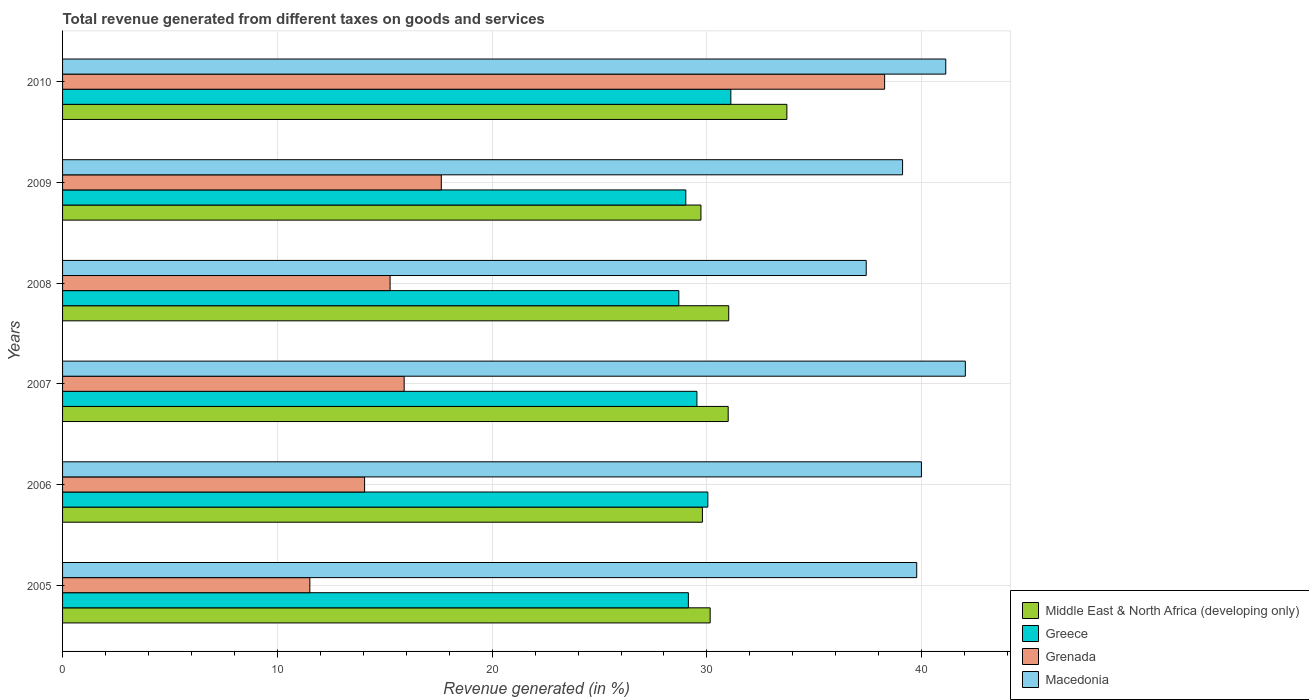How many different coloured bars are there?
Ensure brevity in your answer.  4. How many groups of bars are there?
Keep it short and to the point. 6. Are the number of bars per tick equal to the number of legend labels?
Ensure brevity in your answer.  Yes. What is the label of the 5th group of bars from the top?
Your answer should be compact. 2006. What is the total revenue generated in Middle East & North Africa (developing only) in 2007?
Offer a very short reply. 30.99. Across all years, what is the maximum total revenue generated in Middle East & North Africa (developing only)?
Your answer should be very brief. 33.72. Across all years, what is the minimum total revenue generated in Middle East & North Africa (developing only)?
Keep it short and to the point. 29.72. In which year was the total revenue generated in Middle East & North Africa (developing only) minimum?
Ensure brevity in your answer.  2009. What is the total total revenue generated in Grenada in the graph?
Provide a short and direct response. 112.63. What is the difference between the total revenue generated in Greece in 2005 and that in 2010?
Your answer should be compact. -1.98. What is the difference between the total revenue generated in Greece in 2008 and the total revenue generated in Macedonia in 2007?
Your answer should be very brief. -13.34. What is the average total revenue generated in Macedonia per year?
Your response must be concise. 39.91. In the year 2010, what is the difference between the total revenue generated in Greece and total revenue generated in Middle East & North Africa (developing only)?
Offer a terse response. -2.61. What is the ratio of the total revenue generated in Grenada in 2005 to that in 2009?
Provide a short and direct response. 0.65. Is the difference between the total revenue generated in Greece in 2006 and 2007 greater than the difference between the total revenue generated in Middle East & North Africa (developing only) in 2006 and 2007?
Your answer should be compact. Yes. What is the difference between the highest and the second highest total revenue generated in Greece?
Make the answer very short. 1.07. What is the difference between the highest and the lowest total revenue generated in Grenada?
Your answer should be compact. 26.76. Is the sum of the total revenue generated in Macedonia in 2006 and 2009 greater than the maximum total revenue generated in Middle East & North Africa (developing only) across all years?
Offer a terse response. Yes. Is it the case that in every year, the sum of the total revenue generated in Greece and total revenue generated in Grenada is greater than the sum of total revenue generated in Macedonia and total revenue generated in Middle East & North Africa (developing only)?
Offer a terse response. No. What does the 4th bar from the bottom in 2005 represents?
Your answer should be very brief. Macedonia. How many bars are there?
Make the answer very short. 24. Are all the bars in the graph horizontal?
Provide a succinct answer. Yes. How many years are there in the graph?
Offer a very short reply. 6. What is the difference between two consecutive major ticks on the X-axis?
Your answer should be very brief. 10. Does the graph contain grids?
Offer a very short reply. Yes. How many legend labels are there?
Keep it short and to the point. 4. How are the legend labels stacked?
Provide a succinct answer. Vertical. What is the title of the graph?
Provide a succinct answer. Total revenue generated from different taxes on goods and services. Does "Bolivia" appear as one of the legend labels in the graph?
Your answer should be very brief. No. What is the label or title of the X-axis?
Provide a succinct answer. Revenue generated (in %). What is the Revenue generated (in %) of Middle East & North Africa (developing only) in 2005?
Your answer should be very brief. 30.15. What is the Revenue generated (in %) in Greece in 2005?
Keep it short and to the point. 29.14. What is the Revenue generated (in %) in Grenada in 2005?
Ensure brevity in your answer.  11.51. What is the Revenue generated (in %) of Macedonia in 2005?
Provide a succinct answer. 39.77. What is the Revenue generated (in %) of Middle East & North Africa (developing only) in 2006?
Your answer should be compact. 29.79. What is the Revenue generated (in %) in Greece in 2006?
Make the answer very short. 30.04. What is the Revenue generated (in %) of Grenada in 2006?
Keep it short and to the point. 14.06. What is the Revenue generated (in %) of Macedonia in 2006?
Ensure brevity in your answer.  39.99. What is the Revenue generated (in %) in Middle East & North Africa (developing only) in 2007?
Ensure brevity in your answer.  30.99. What is the Revenue generated (in %) in Greece in 2007?
Your response must be concise. 29.53. What is the Revenue generated (in %) of Grenada in 2007?
Offer a terse response. 15.9. What is the Revenue generated (in %) of Macedonia in 2007?
Offer a very short reply. 42.03. What is the Revenue generated (in %) in Middle East & North Africa (developing only) in 2008?
Give a very brief answer. 31.02. What is the Revenue generated (in %) in Greece in 2008?
Your response must be concise. 28.69. What is the Revenue generated (in %) of Grenada in 2008?
Offer a very short reply. 15.25. What is the Revenue generated (in %) in Macedonia in 2008?
Keep it short and to the point. 37.42. What is the Revenue generated (in %) of Middle East & North Africa (developing only) in 2009?
Ensure brevity in your answer.  29.72. What is the Revenue generated (in %) of Greece in 2009?
Your answer should be very brief. 29.02. What is the Revenue generated (in %) of Grenada in 2009?
Offer a very short reply. 17.63. What is the Revenue generated (in %) in Macedonia in 2009?
Your response must be concise. 39.11. What is the Revenue generated (in %) of Middle East & North Africa (developing only) in 2010?
Your answer should be compact. 33.72. What is the Revenue generated (in %) in Greece in 2010?
Provide a short and direct response. 31.11. What is the Revenue generated (in %) in Grenada in 2010?
Offer a very short reply. 38.27. What is the Revenue generated (in %) of Macedonia in 2010?
Offer a terse response. 41.12. Across all years, what is the maximum Revenue generated (in %) in Middle East & North Africa (developing only)?
Offer a terse response. 33.72. Across all years, what is the maximum Revenue generated (in %) in Greece?
Ensure brevity in your answer.  31.11. Across all years, what is the maximum Revenue generated (in %) in Grenada?
Ensure brevity in your answer.  38.27. Across all years, what is the maximum Revenue generated (in %) in Macedonia?
Ensure brevity in your answer.  42.03. Across all years, what is the minimum Revenue generated (in %) in Middle East & North Africa (developing only)?
Offer a very short reply. 29.72. Across all years, what is the minimum Revenue generated (in %) of Greece?
Ensure brevity in your answer.  28.69. Across all years, what is the minimum Revenue generated (in %) in Grenada?
Give a very brief answer. 11.51. Across all years, what is the minimum Revenue generated (in %) of Macedonia?
Give a very brief answer. 37.42. What is the total Revenue generated (in %) in Middle East & North Africa (developing only) in the graph?
Your answer should be very brief. 185.39. What is the total Revenue generated (in %) in Greece in the graph?
Provide a short and direct response. 177.54. What is the total Revenue generated (in %) of Grenada in the graph?
Give a very brief answer. 112.63. What is the total Revenue generated (in %) in Macedonia in the graph?
Keep it short and to the point. 239.43. What is the difference between the Revenue generated (in %) of Middle East & North Africa (developing only) in 2005 and that in 2006?
Provide a short and direct response. 0.36. What is the difference between the Revenue generated (in %) of Greece in 2005 and that in 2006?
Offer a very short reply. -0.91. What is the difference between the Revenue generated (in %) of Grenada in 2005 and that in 2006?
Your answer should be very brief. -2.55. What is the difference between the Revenue generated (in %) in Macedonia in 2005 and that in 2006?
Give a very brief answer. -0.22. What is the difference between the Revenue generated (in %) in Middle East & North Africa (developing only) in 2005 and that in 2007?
Make the answer very short. -0.84. What is the difference between the Revenue generated (in %) in Greece in 2005 and that in 2007?
Your response must be concise. -0.4. What is the difference between the Revenue generated (in %) of Grenada in 2005 and that in 2007?
Give a very brief answer. -4.39. What is the difference between the Revenue generated (in %) of Macedonia in 2005 and that in 2007?
Provide a short and direct response. -2.26. What is the difference between the Revenue generated (in %) of Middle East & North Africa (developing only) in 2005 and that in 2008?
Your response must be concise. -0.86. What is the difference between the Revenue generated (in %) in Greece in 2005 and that in 2008?
Offer a very short reply. 0.44. What is the difference between the Revenue generated (in %) of Grenada in 2005 and that in 2008?
Your response must be concise. -3.74. What is the difference between the Revenue generated (in %) of Macedonia in 2005 and that in 2008?
Give a very brief answer. 2.35. What is the difference between the Revenue generated (in %) of Middle East & North Africa (developing only) in 2005 and that in 2009?
Your response must be concise. 0.43. What is the difference between the Revenue generated (in %) in Greece in 2005 and that in 2009?
Make the answer very short. 0.12. What is the difference between the Revenue generated (in %) in Grenada in 2005 and that in 2009?
Make the answer very short. -6.12. What is the difference between the Revenue generated (in %) in Macedonia in 2005 and that in 2009?
Provide a short and direct response. 0.66. What is the difference between the Revenue generated (in %) in Middle East & North Africa (developing only) in 2005 and that in 2010?
Provide a short and direct response. -3.57. What is the difference between the Revenue generated (in %) of Greece in 2005 and that in 2010?
Give a very brief answer. -1.98. What is the difference between the Revenue generated (in %) of Grenada in 2005 and that in 2010?
Give a very brief answer. -26.76. What is the difference between the Revenue generated (in %) in Macedonia in 2005 and that in 2010?
Give a very brief answer. -1.35. What is the difference between the Revenue generated (in %) of Middle East & North Africa (developing only) in 2006 and that in 2007?
Your response must be concise. -1.2. What is the difference between the Revenue generated (in %) in Greece in 2006 and that in 2007?
Your answer should be very brief. 0.51. What is the difference between the Revenue generated (in %) in Grenada in 2006 and that in 2007?
Make the answer very short. -1.84. What is the difference between the Revenue generated (in %) of Macedonia in 2006 and that in 2007?
Provide a succinct answer. -2.04. What is the difference between the Revenue generated (in %) of Middle East & North Africa (developing only) in 2006 and that in 2008?
Your answer should be compact. -1.22. What is the difference between the Revenue generated (in %) in Greece in 2006 and that in 2008?
Offer a very short reply. 1.35. What is the difference between the Revenue generated (in %) in Grenada in 2006 and that in 2008?
Keep it short and to the point. -1.19. What is the difference between the Revenue generated (in %) of Macedonia in 2006 and that in 2008?
Offer a terse response. 2.57. What is the difference between the Revenue generated (in %) of Middle East & North Africa (developing only) in 2006 and that in 2009?
Give a very brief answer. 0.07. What is the difference between the Revenue generated (in %) of Greece in 2006 and that in 2009?
Provide a succinct answer. 1.03. What is the difference between the Revenue generated (in %) in Grenada in 2006 and that in 2009?
Your answer should be compact. -3.57. What is the difference between the Revenue generated (in %) of Macedonia in 2006 and that in 2009?
Your response must be concise. 0.88. What is the difference between the Revenue generated (in %) of Middle East & North Africa (developing only) in 2006 and that in 2010?
Offer a very short reply. -3.93. What is the difference between the Revenue generated (in %) in Greece in 2006 and that in 2010?
Offer a very short reply. -1.07. What is the difference between the Revenue generated (in %) of Grenada in 2006 and that in 2010?
Offer a very short reply. -24.21. What is the difference between the Revenue generated (in %) of Macedonia in 2006 and that in 2010?
Keep it short and to the point. -1.13. What is the difference between the Revenue generated (in %) in Middle East & North Africa (developing only) in 2007 and that in 2008?
Provide a succinct answer. -0.03. What is the difference between the Revenue generated (in %) of Greece in 2007 and that in 2008?
Ensure brevity in your answer.  0.84. What is the difference between the Revenue generated (in %) of Grenada in 2007 and that in 2008?
Your answer should be compact. 0.66. What is the difference between the Revenue generated (in %) in Macedonia in 2007 and that in 2008?
Your answer should be very brief. 4.62. What is the difference between the Revenue generated (in %) in Middle East & North Africa (developing only) in 2007 and that in 2009?
Provide a short and direct response. 1.27. What is the difference between the Revenue generated (in %) in Greece in 2007 and that in 2009?
Provide a succinct answer. 0.52. What is the difference between the Revenue generated (in %) of Grenada in 2007 and that in 2009?
Keep it short and to the point. -1.73. What is the difference between the Revenue generated (in %) of Macedonia in 2007 and that in 2009?
Your response must be concise. 2.92. What is the difference between the Revenue generated (in %) in Middle East & North Africa (developing only) in 2007 and that in 2010?
Offer a very short reply. -2.73. What is the difference between the Revenue generated (in %) in Greece in 2007 and that in 2010?
Offer a terse response. -1.58. What is the difference between the Revenue generated (in %) in Grenada in 2007 and that in 2010?
Your answer should be very brief. -22.37. What is the difference between the Revenue generated (in %) in Macedonia in 2007 and that in 2010?
Ensure brevity in your answer.  0.91. What is the difference between the Revenue generated (in %) of Middle East & North Africa (developing only) in 2008 and that in 2009?
Your answer should be compact. 1.29. What is the difference between the Revenue generated (in %) of Greece in 2008 and that in 2009?
Ensure brevity in your answer.  -0.32. What is the difference between the Revenue generated (in %) of Grenada in 2008 and that in 2009?
Your response must be concise. -2.38. What is the difference between the Revenue generated (in %) in Macedonia in 2008 and that in 2009?
Keep it short and to the point. -1.69. What is the difference between the Revenue generated (in %) of Middle East & North Africa (developing only) in 2008 and that in 2010?
Your answer should be very brief. -2.71. What is the difference between the Revenue generated (in %) of Greece in 2008 and that in 2010?
Your response must be concise. -2.42. What is the difference between the Revenue generated (in %) in Grenada in 2008 and that in 2010?
Your answer should be compact. -23.02. What is the difference between the Revenue generated (in %) in Macedonia in 2008 and that in 2010?
Provide a short and direct response. -3.7. What is the difference between the Revenue generated (in %) in Middle East & North Africa (developing only) in 2009 and that in 2010?
Ensure brevity in your answer.  -4. What is the difference between the Revenue generated (in %) of Greece in 2009 and that in 2010?
Your answer should be compact. -2.1. What is the difference between the Revenue generated (in %) in Grenada in 2009 and that in 2010?
Offer a very short reply. -20.64. What is the difference between the Revenue generated (in %) of Macedonia in 2009 and that in 2010?
Offer a terse response. -2.01. What is the difference between the Revenue generated (in %) of Middle East & North Africa (developing only) in 2005 and the Revenue generated (in %) of Greece in 2006?
Your answer should be compact. 0.11. What is the difference between the Revenue generated (in %) of Middle East & North Africa (developing only) in 2005 and the Revenue generated (in %) of Grenada in 2006?
Your response must be concise. 16.09. What is the difference between the Revenue generated (in %) in Middle East & North Africa (developing only) in 2005 and the Revenue generated (in %) in Macedonia in 2006?
Ensure brevity in your answer.  -9.84. What is the difference between the Revenue generated (in %) in Greece in 2005 and the Revenue generated (in %) in Grenada in 2006?
Provide a short and direct response. 15.07. What is the difference between the Revenue generated (in %) of Greece in 2005 and the Revenue generated (in %) of Macedonia in 2006?
Make the answer very short. -10.85. What is the difference between the Revenue generated (in %) in Grenada in 2005 and the Revenue generated (in %) in Macedonia in 2006?
Give a very brief answer. -28.47. What is the difference between the Revenue generated (in %) of Middle East & North Africa (developing only) in 2005 and the Revenue generated (in %) of Greece in 2007?
Your answer should be compact. 0.62. What is the difference between the Revenue generated (in %) of Middle East & North Africa (developing only) in 2005 and the Revenue generated (in %) of Grenada in 2007?
Ensure brevity in your answer.  14.25. What is the difference between the Revenue generated (in %) of Middle East & North Africa (developing only) in 2005 and the Revenue generated (in %) of Macedonia in 2007?
Ensure brevity in your answer.  -11.88. What is the difference between the Revenue generated (in %) in Greece in 2005 and the Revenue generated (in %) in Grenada in 2007?
Keep it short and to the point. 13.23. What is the difference between the Revenue generated (in %) of Greece in 2005 and the Revenue generated (in %) of Macedonia in 2007?
Your response must be concise. -12.9. What is the difference between the Revenue generated (in %) in Grenada in 2005 and the Revenue generated (in %) in Macedonia in 2007?
Offer a terse response. -30.52. What is the difference between the Revenue generated (in %) in Middle East & North Africa (developing only) in 2005 and the Revenue generated (in %) in Greece in 2008?
Keep it short and to the point. 1.46. What is the difference between the Revenue generated (in %) in Middle East & North Africa (developing only) in 2005 and the Revenue generated (in %) in Grenada in 2008?
Give a very brief answer. 14.9. What is the difference between the Revenue generated (in %) of Middle East & North Africa (developing only) in 2005 and the Revenue generated (in %) of Macedonia in 2008?
Make the answer very short. -7.27. What is the difference between the Revenue generated (in %) of Greece in 2005 and the Revenue generated (in %) of Grenada in 2008?
Make the answer very short. 13.89. What is the difference between the Revenue generated (in %) of Greece in 2005 and the Revenue generated (in %) of Macedonia in 2008?
Keep it short and to the point. -8.28. What is the difference between the Revenue generated (in %) of Grenada in 2005 and the Revenue generated (in %) of Macedonia in 2008?
Keep it short and to the point. -25.9. What is the difference between the Revenue generated (in %) in Middle East & North Africa (developing only) in 2005 and the Revenue generated (in %) in Greece in 2009?
Ensure brevity in your answer.  1.13. What is the difference between the Revenue generated (in %) in Middle East & North Africa (developing only) in 2005 and the Revenue generated (in %) in Grenada in 2009?
Keep it short and to the point. 12.52. What is the difference between the Revenue generated (in %) in Middle East & North Africa (developing only) in 2005 and the Revenue generated (in %) in Macedonia in 2009?
Provide a succinct answer. -8.96. What is the difference between the Revenue generated (in %) of Greece in 2005 and the Revenue generated (in %) of Grenada in 2009?
Keep it short and to the point. 11.5. What is the difference between the Revenue generated (in %) in Greece in 2005 and the Revenue generated (in %) in Macedonia in 2009?
Your answer should be very brief. -9.97. What is the difference between the Revenue generated (in %) in Grenada in 2005 and the Revenue generated (in %) in Macedonia in 2009?
Your answer should be very brief. -27.6. What is the difference between the Revenue generated (in %) of Middle East & North Africa (developing only) in 2005 and the Revenue generated (in %) of Greece in 2010?
Offer a very short reply. -0.96. What is the difference between the Revenue generated (in %) of Middle East & North Africa (developing only) in 2005 and the Revenue generated (in %) of Grenada in 2010?
Your answer should be very brief. -8.12. What is the difference between the Revenue generated (in %) in Middle East & North Africa (developing only) in 2005 and the Revenue generated (in %) in Macedonia in 2010?
Give a very brief answer. -10.97. What is the difference between the Revenue generated (in %) of Greece in 2005 and the Revenue generated (in %) of Grenada in 2010?
Offer a terse response. -9.14. What is the difference between the Revenue generated (in %) in Greece in 2005 and the Revenue generated (in %) in Macedonia in 2010?
Your response must be concise. -11.98. What is the difference between the Revenue generated (in %) of Grenada in 2005 and the Revenue generated (in %) of Macedonia in 2010?
Ensure brevity in your answer.  -29.61. What is the difference between the Revenue generated (in %) in Middle East & North Africa (developing only) in 2006 and the Revenue generated (in %) in Greece in 2007?
Ensure brevity in your answer.  0.26. What is the difference between the Revenue generated (in %) of Middle East & North Africa (developing only) in 2006 and the Revenue generated (in %) of Grenada in 2007?
Ensure brevity in your answer.  13.89. What is the difference between the Revenue generated (in %) of Middle East & North Africa (developing only) in 2006 and the Revenue generated (in %) of Macedonia in 2007?
Your answer should be very brief. -12.24. What is the difference between the Revenue generated (in %) in Greece in 2006 and the Revenue generated (in %) in Grenada in 2007?
Provide a short and direct response. 14.14. What is the difference between the Revenue generated (in %) of Greece in 2006 and the Revenue generated (in %) of Macedonia in 2007?
Offer a terse response. -11.99. What is the difference between the Revenue generated (in %) of Grenada in 2006 and the Revenue generated (in %) of Macedonia in 2007?
Make the answer very short. -27.97. What is the difference between the Revenue generated (in %) in Middle East & North Africa (developing only) in 2006 and the Revenue generated (in %) in Greece in 2008?
Your answer should be compact. 1.1. What is the difference between the Revenue generated (in %) of Middle East & North Africa (developing only) in 2006 and the Revenue generated (in %) of Grenada in 2008?
Offer a terse response. 14.54. What is the difference between the Revenue generated (in %) of Middle East & North Africa (developing only) in 2006 and the Revenue generated (in %) of Macedonia in 2008?
Keep it short and to the point. -7.63. What is the difference between the Revenue generated (in %) in Greece in 2006 and the Revenue generated (in %) in Grenada in 2008?
Your answer should be compact. 14.79. What is the difference between the Revenue generated (in %) of Greece in 2006 and the Revenue generated (in %) of Macedonia in 2008?
Provide a short and direct response. -7.37. What is the difference between the Revenue generated (in %) in Grenada in 2006 and the Revenue generated (in %) in Macedonia in 2008?
Provide a succinct answer. -23.36. What is the difference between the Revenue generated (in %) in Middle East & North Africa (developing only) in 2006 and the Revenue generated (in %) in Greece in 2009?
Offer a terse response. 0.77. What is the difference between the Revenue generated (in %) of Middle East & North Africa (developing only) in 2006 and the Revenue generated (in %) of Grenada in 2009?
Give a very brief answer. 12.16. What is the difference between the Revenue generated (in %) of Middle East & North Africa (developing only) in 2006 and the Revenue generated (in %) of Macedonia in 2009?
Offer a very short reply. -9.32. What is the difference between the Revenue generated (in %) in Greece in 2006 and the Revenue generated (in %) in Grenada in 2009?
Provide a succinct answer. 12.41. What is the difference between the Revenue generated (in %) in Greece in 2006 and the Revenue generated (in %) in Macedonia in 2009?
Offer a terse response. -9.07. What is the difference between the Revenue generated (in %) of Grenada in 2006 and the Revenue generated (in %) of Macedonia in 2009?
Your answer should be compact. -25.05. What is the difference between the Revenue generated (in %) in Middle East & North Africa (developing only) in 2006 and the Revenue generated (in %) in Greece in 2010?
Your answer should be compact. -1.32. What is the difference between the Revenue generated (in %) in Middle East & North Africa (developing only) in 2006 and the Revenue generated (in %) in Grenada in 2010?
Your answer should be very brief. -8.48. What is the difference between the Revenue generated (in %) in Middle East & North Africa (developing only) in 2006 and the Revenue generated (in %) in Macedonia in 2010?
Ensure brevity in your answer.  -11.33. What is the difference between the Revenue generated (in %) of Greece in 2006 and the Revenue generated (in %) of Grenada in 2010?
Your response must be concise. -8.23. What is the difference between the Revenue generated (in %) of Greece in 2006 and the Revenue generated (in %) of Macedonia in 2010?
Give a very brief answer. -11.08. What is the difference between the Revenue generated (in %) in Grenada in 2006 and the Revenue generated (in %) in Macedonia in 2010?
Ensure brevity in your answer.  -27.06. What is the difference between the Revenue generated (in %) in Middle East & North Africa (developing only) in 2007 and the Revenue generated (in %) in Greece in 2008?
Your answer should be compact. 2.3. What is the difference between the Revenue generated (in %) in Middle East & North Africa (developing only) in 2007 and the Revenue generated (in %) in Grenada in 2008?
Keep it short and to the point. 15.74. What is the difference between the Revenue generated (in %) in Middle East & North Africa (developing only) in 2007 and the Revenue generated (in %) in Macedonia in 2008?
Your answer should be very brief. -6.43. What is the difference between the Revenue generated (in %) in Greece in 2007 and the Revenue generated (in %) in Grenada in 2008?
Provide a short and direct response. 14.29. What is the difference between the Revenue generated (in %) in Greece in 2007 and the Revenue generated (in %) in Macedonia in 2008?
Give a very brief answer. -7.88. What is the difference between the Revenue generated (in %) of Grenada in 2007 and the Revenue generated (in %) of Macedonia in 2008?
Your answer should be compact. -21.51. What is the difference between the Revenue generated (in %) in Middle East & North Africa (developing only) in 2007 and the Revenue generated (in %) in Greece in 2009?
Your answer should be very brief. 1.97. What is the difference between the Revenue generated (in %) in Middle East & North Africa (developing only) in 2007 and the Revenue generated (in %) in Grenada in 2009?
Provide a short and direct response. 13.36. What is the difference between the Revenue generated (in %) in Middle East & North Africa (developing only) in 2007 and the Revenue generated (in %) in Macedonia in 2009?
Your response must be concise. -8.12. What is the difference between the Revenue generated (in %) in Greece in 2007 and the Revenue generated (in %) in Grenada in 2009?
Provide a short and direct response. 11.9. What is the difference between the Revenue generated (in %) of Greece in 2007 and the Revenue generated (in %) of Macedonia in 2009?
Make the answer very short. -9.58. What is the difference between the Revenue generated (in %) in Grenada in 2007 and the Revenue generated (in %) in Macedonia in 2009?
Your response must be concise. -23.21. What is the difference between the Revenue generated (in %) in Middle East & North Africa (developing only) in 2007 and the Revenue generated (in %) in Greece in 2010?
Your answer should be compact. -0.12. What is the difference between the Revenue generated (in %) of Middle East & North Africa (developing only) in 2007 and the Revenue generated (in %) of Grenada in 2010?
Your answer should be compact. -7.28. What is the difference between the Revenue generated (in %) in Middle East & North Africa (developing only) in 2007 and the Revenue generated (in %) in Macedonia in 2010?
Your response must be concise. -10.13. What is the difference between the Revenue generated (in %) of Greece in 2007 and the Revenue generated (in %) of Grenada in 2010?
Your answer should be compact. -8.74. What is the difference between the Revenue generated (in %) of Greece in 2007 and the Revenue generated (in %) of Macedonia in 2010?
Ensure brevity in your answer.  -11.59. What is the difference between the Revenue generated (in %) of Grenada in 2007 and the Revenue generated (in %) of Macedonia in 2010?
Provide a succinct answer. -25.22. What is the difference between the Revenue generated (in %) in Middle East & North Africa (developing only) in 2008 and the Revenue generated (in %) in Greece in 2009?
Offer a very short reply. 2. What is the difference between the Revenue generated (in %) in Middle East & North Africa (developing only) in 2008 and the Revenue generated (in %) in Grenada in 2009?
Provide a short and direct response. 13.38. What is the difference between the Revenue generated (in %) in Middle East & North Africa (developing only) in 2008 and the Revenue generated (in %) in Macedonia in 2009?
Your answer should be compact. -8.09. What is the difference between the Revenue generated (in %) of Greece in 2008 and the Revenue generated (in %) of Grenada in 2009?
Your response must be concise. 11.06. What is the difference between the Revenue generated (in %) in Greece in 2008 and the Revenue generated (in %) in Macedonia in 2009?
Keep it short and to the point. -10.42. What is the difference between the Revenue generated (in %) in Grenada in 2008 and the Revenue generated (in %) in Macedonia in 2009?
Offer a very short reply. -23.86. What is the difference between the Revenue generated (in %) in Middle East & North Africa (developing only) in 2008 and the Revenue generated (in %) in Greece in 2010?
Give a very brief answer. -0.1. What is the difference between the Revenue generated (in %) in Middle East & North Africa (developing only) in 2008 and the Revenue generated (in %) in Grenada in 2010?
Offer a very short reply. -7.26. What is the difference between the Revenue generated (in %) of Middle East & North Africa (developing only) in 2008 and the Revenue generated (in %) of Macedonia in 2010?
Your answer should be very brief. -10.1. What is the difference between the Revenue generated (in %) in Greece in 2008 and the Revenue generated (in %) in Grenada in 2010?
Give a very brief answer. -9.58. What is the difference between the Revenue generated (in %) of Greece in 2008 and the Revenue generated (in %) of Macedonia in 2010?
Provide a short and direct response. -12.43. What is the difference between the Revenue generated (in %) of Grenada in 2008 and the Revenue generated (in %) of Macedonia in 2010?
Offer a very short reply. -25.87. What is the difference between the Revenue generated (in %) in Middle East & North Africa (developing only) in 2009 and the Revenue generated (in %) in Greece in 2010?
Make the answer very short. -1.39. What is the difference between the Revenue generated (in %) of Middle East & North Africa (developing only) in 2009 and the Revenue generated (in %) of Grenada in 2010?
Offer a very short reply. -8.55. What is the difference between the Revenue generated (in %) in Middle East & North Africa (developing only) in 2009 and the Revenue generated (in %) in Macedonia in 2010?
Provide a succinct answer. -11.4. What is the difference between the Revenue generated (in %) of Greece in 2009 and the Revenue generated (in %) of Grenada in 2010?
Give a very brief answer. -9.26. What is the difference between the Revenue generated (in %) in Greece in 2009 and the Revenue generated (in %) in Macedonia in 2010?
Your answer should be compact. -12.1. What is the difference between the Revenue generated (in %) of Grenada in 2009 and the Revenue generated (in %) of Macedonia in 2010?
Your response must be concise. -23.49. What is the average Revenue generated (in %) in Middle East & North Africa (developing only) per year?
Your answer should be very brief. 30.9. What is the average Revenue generated (in %) in Greece per year?
Give a very brief answer. 29.59. What is the average Revenue generated (in %) in Grenada per year?
Your response must be concise. 18.77. What is the average Revenue generated (in %) in Macedonia per year?
Make the answer very short. 39.91. In the year 2005, what is the difference between the Revenue generated (in %) of Middle East & North Africa (developing only) and Revenue generated (in %) of Greece?
Your response must be concise. 1.01. In the year 2005, what is the difference between the Revenue generated (in %) of Middle East & North Africa (developing only) and Revenue generated (in %) of Grenada?
Keep it short and to the point. 18.64. In the year 2005, what is the difference between the Revenue generated (in %) in Middle East & North Africa (developing only) and Revenue generated (in %) in Macedonia?
Your response must be concise. -9.62. In the year 2005, what is the difference between the Revenue generated (in %) in Greece and Revenue generated (in %) in Grenada?
Keep it short and to the point. 17.62. In the year 2005, what is the difference between the Revenue generated (in %) in Greece and Revenue generated (in %) in Macedonia?
Ensure brevity in your answer.  -10.63. In the year 2005, what is the difference between the Revenue generated (in %) in Grenada and Revenue generated (in %) in Macedonia?
Provide a succinct answer. -28.25. In the year 2006, what is the difference between the Revenue generated (in %) in Middle East & North Africa (developing only) and Revenue generated (in %) in Greece?
Give a very brief answer. -0.25. In the year 2006, what is the difference between the Revenue generated (in %) in Middle East & North Africa (developing only) and Revenue generated (in %) in Grenada?
Ensure brevity in your answer.  15.73. In the year 2006, what is the difference between the Revenue generated (in %) in Middle East & North Africa (developing only) and Revenue generated (in %) in Macedonia?
Ensure brevity in your answer.  -10.2. In the year 2006, what is the difference between the Revenue generated (in %) of Greece and Revenue generated (in %) of Grenada?
Offer a terse response. 15.98. In the year 2006, what is the difference between the Revenue generated (in %) in Greece and Revenue generated (in %) in Macedonia?
Provide a succinct answer. -9.94. In the year 2006, what is the difference between the Revenue generated (in %) of Grenada and Revenue generated (in %) of Macedonia?
Make the answer very short. -25.93. In the year 2007, what is the difference between the Revenue generated (in %) of Middle East & North Africa (developing only) and Revenue generated (in %) of Greece?
Keep it short and to the point. 1.46. In the year 2007, what is the difference between the Revenue generated (in %) of Middle East & North Africa (developing only) and Revenue generated (in %) of Grenada?
Offer a terse response. 15.09. In the year 2007, what is the difference between the Revenue generated (in %) of Middle East & North Africa (developing only) and Revenue generated (in %) of Macedonia?
Give a very brief answer. -11.04. In the year 2007, what is the difference between the Revenue generated (in %) of Greece and Revenue generated (in %) of Grenada?
Offer a very short reply. 13.63. In the year 2007, what is the difference between the Revenue generated (in %) of Greece and Revenue generated (in %) of Macedonia?
Ensure brevity in your answer.  -12.5. In the year 2007, what is the difference between the Revenue generated (in %) of Grenada and Revenue generated (in %) of Macedonia?
Your response must be concise. -26.13. In the year 2008, what is the difference between the Revenue generated (in %) of Middle East & North Africa (developing only) and Revenue generated (in %) of Greece?
Provide a succinct answer. 2.32. In the year 2008, what is the difference between the Revenue generated (in %) of Middle East & North Africa (developing only) and Revenue generated (in %) of Grenada?
Your response must be concise. 15.77. In the year 2008, what is the difference between the Revenue generated (in %) of Middle East & North Africa (developing only) and Revenue generated (in %) of Macedonia?
Your answer should be very brief. -6.4. In the year 2008, what is the difference between the Revenue generated (in %) in Greece and Revenue generated (in %) in Grenada?
Provide a succinct answer. 13.44. In the year 2008, what is the difference between the Revenue generated (in %) in Greece and Revenue generated (in %) in Macedonia?
Make the answer very short. -8.72. In the year 2008, what is the difference between the Revenue generated (in %) in Grenada and Revenue generated (in %) in Macedonia?
Ensure brevity in your answer.  -22.17. In the year 2009, what is the difference between the Revenue generated (in %) of Middle East & North Africa (developing only) and Revenue generated (in %) of Greece?
Give a very brief answer. 0.7. In the year 2009, what is the difference between the Revenue generated (in %) of Middle East & North Africa (developing only) and Revenue generated (in %) of Grenada?
Make the answer very short. 12.09. In the year 2009, what is the difference between the Revenue generated (in %) of Middle East & North Africa (developing only) and Revenue generated (in %) of Macedonia?
Keep it short and to the point. -9.39. In the year 2009, what is the difference between the Revenue generated (in %) of Greece and Revenue generated (in %) of Grenada?
Provide a succinct answer. 11.38. In the year 2009, what is the difference between the Revenue generated (in %) of Greece and Revenue generated (in %) of Macedonia?
Provide a short and direct response. -10.09. In the year 2009, what is the difference between the Revenue generated (in %) of Grenada and Revenue generated (in %) of Macedonia?
Offer a terse response. -21.48. In the year 2010, what is the difference between the Revenue generated (in %) of Middle East & North Africa (developing only) and Revenue generated (in %) of Greece?
Offer a terse response. 2.61. In the year 2010, what is the difference between the Revenue generated (in %) of Middle East & North Africa (developing only) and Revenue generated (in %) of Grenada?
Your answer should be very brief. -4.55. In the year 2010, what is the difference between the Revenue generated (in %) of Middle East & North Africa (developing only) and Revenue generated (in %) of Macedonia?
Your response must be concise. -7.4. In the year 2010, what is the difference between the Revenue generated (in %) of Greece and Revenue generated (in %) of Grenada?
Offer a very short reply. -7.16. In the year 2010, what is the difference between the Revenue generated (in %) in Greece and Revenue generated (in %) in Macedonia?
Your answer should be compact. -10.01. In the year 2010, what is the difference between the Revenue generated (in %) in Grenada and Revenue generated (in %) in Macedonia?
Your response must be concise. -2.85. What is the ratio of the Revenue generated (in %) in Middle East & North Africa (developing only) in 2005 to that in 2006?
Your answer should be very brief. 1.01. What is the ratio of the Revenue generated (in %) in Greece in 2005 to that in 2006?
Ensure brevity in your answer.  0.97. What is the ratio of the Revenue generated (in %) of Grenada in 2005 to that in 2006?
Ensure brevity in your answer.  0.82. What is the ratio of the Revenue generated (in %) in Macedonia in 2005 to that in 2006?
Your answer should be compact. 0.99. What is the ratio of the Revenue generated (in %) in Middle East & North Africa (developing only) in 2005 to that in 2007?
Provide a succinct answer. 0.97. What is the ratio of the Revenue generated (in %) of Greece in 2005 to that in 2007?
Provide a short and direct response. 0.99. What is the ratio of the Revenue generated (in %) of Grenada in 2005 to that in 2007?
Make the answer very short. 0.72. What is the ratio of the Revenue generated (in %) in Macedonia in 2005 to that in 2007?
Keep it short and to the point. 0.95. What is the ratio of the Revenue generated (in %) in Middle East & North Africa (developing only) in 2005 to that in 2008?
Your answer should be compact. 0.97. What is the ratio of the Revenue generated (in %) of Greece in 2005 to that in 2008?
Offer a very short reply. 1.02. What is the ratio of the Revenue generated (in %) of Grenada in 2005 to that in 2008?
Offer a very short reply. 0.76. What is the ratio of the Revenue generated (in %) in Macedonia in 2005 to that in 2008?
Your response must be concise. 1.06. What is the ratio of the Revenue generated (in %) of Middle East & North Africa (developing only) in 2005 to that in 2009?
Provide a succinct answer. 1.01. What is the ratio of the Revenue generated (in %) in Greece in 2005 to that in 2009?
Your answer should be very brief. 1. What is the ratio of the Revenue generated (in %) in Grenada in 2005 to that in 2009?
Your response must be concise. 0.65. What is the ratio of the Revenue generated (in %) of Macedonia in 2005 to that in 2009?
Ensure brevity in your answer.  1.02. What is the ratio of the Revenue generated (in %) in Middle East & North Africa (developing only) in 2005 to that in 2010?
Give a very brief answer. 0.89. What is the ratio of the Revenue generated (in %) of Greece in 2005 to that in 2010?
Keep it short and to the point. 0.94. What is the ratio of the Revenue generated (in %) of Grenada in 2005 to that in 2010?
Give a very brief answer. 0.3. What is the ratio of the Revenue generated (in %) in Macedonia in 2005 to that in 2010?
Give a very brief answer. 0.97. What is the ratio of the Revenue generated (in %) of Middle East & North Africa (developing only) in 2006 to that in 2007?
Ensure brevity in your answer.  0.96. What is the ratio of the Revenue generated (in %) of Greece in 2006 to that in 2007?
Your answer should be compact. 1.02. What is the ratio of the Revenue generated (in %) of Grenada in 2006 to that in 2007?
Your answer should be very brief. 0.88. What is the ratio of the Revenue generated (in %) in Macedonia in 2006 to that in 2007?
Make the answer very short. 0.95. What is the ratio of the Revenue generated (in %) of Middle East & North Africa (developing only) in 2006 to that in 2008?
Your answer should be very brief. 0.96. What is the ratio of the Revenue generated (in %) of Greece in 2006 to that in 2008?
Offer a terse response. 1.05. What is the ratio of the Revenue generated (in %) in Grenada in 2006 to that in 2008?
Offer a very short reply. 0.92. What is the ratio of the Revenue generated (in %) in Macedonia in 2006 to that in 2008?
Provide a succinct answer. 1.07. What is the ratio of the Revenue generated (in %) in Middle East & North Africa (developing only) in 2006 to that in 2009?
Keep it short and to the point. 1. What is the ratio of the Revenue generated (in %) of Greece in 2006 to that in 2009?
Offer a terse response. 1.04. What is the ratio of the Revenue generated (in %) in Grenada in 2006 to that in 2009?
Your answer should be compact. 0.8. What is the ratio of the Revenue generated (in %) of Macedonia in 2006 to that in 2009?
Give a very brief answer. 1.02. What is the ratio of the Revenue generated (in %) in Middle East & North Africa (developing only) in 2006 to that in 2010?
Your answer should be very brief. 0.88. What is the ratio of the Revenue generated (in %) in Greece in 2006 to that in 2010?
Offer a terse response. 0.97. What is the ratio of the Revenue generated (in %) of Grenada in 2006 to that in 2010?
Offer a terse response. 0.37. What is the ratio of the Revenue generated (in %) in Macedonia in 2006 to that in 2010?
Your answer should be very brief. 0.97. What is the ratio of the Revenue generated (in %) of Middle East & North Africa (developing only) in 2007 to that in 2008?
Make the answer very short. 1. What is the ratio of the Revenue generated (in %) of Greece in 2007 to that in 2008?
Provide a short and direct response. 1.03. What is the ratio of the Revenue generated (in %) in Grenada in 2007 to that in 2008?
Provide a short and direct response. 1.04. What is the ratio of the Revenue generated (in %) in Macedonia in 2007 to that in 2008?
Offer a terse response. 1.12. What is the ratio of the Revenue generated (in %) in Middle East & North Africa (developing only) in 2007 to that in 2009?
Provide a succinct answer. 1.04. What is the ratio of the Revenue generated (in %) of Greece in 2007 to that in 2009?
Give a very brief answer. 1.02. What is the ratio of the Revenue generated (in %) in Grenada in 2007 to that in 2009?
Your response must be concise. 0.9. What is the ratio of the Revenue generated (in %) of Macedonia in 2007 to that in 2009?
Your response must be concise. 1.07. What is the ratio of the Revenue generated (in %) of Middle East & North Africa (developing only) in 2007 to that in 2010?
Offer a very short reply. 0.92. What is the ratio of the Revenue generated (in %) of Greece in 2007 to that in 2010?
Your answer should be very brief. 0.95. What is the ratio of the Revenue generated (in %) in Grenada in 2007 to that in 2010?
Ensure brevity in your answer.  0.42. What is the ratio of the Revenue generated (in %) of Macedonia in 2007 to that in 2010?
Offer a very short reply. 1.02. What is the ratio of the Revenue generated (in %) of Middle East & North Africa (developing only) in 2008 to that in 2009?
Make the answer very short. 1.04. What is the ratio of the Revenue generated (in %) of Greece in 2008 to that in 2009?
Provide a short and direct response. 0.99. What is the ratio of the Revenue generated (in %) in Grenada in 2008 to that in 2009?
Your answer should be very brief. 0.86. What is the ratio of the Revenue generated (in %) in Macedonia in 2008 to that in 2009?
Provide a short and direct response. 0.96. What is the ratio of the Revenue generated (in %) of Middle East & North Africa (developing only) in 2008 to that in 2010?
Offer a terse response. 0.92. What is the ratio of the Revenue generated (in %) of Greece in 2008 to that in 2010?
Make the answer very short. 0.92. What is the ratio of the Revenue generated (in %) in Grenada in 2008 to that in 2010?
Give a very brief answer. 0.4. What is the ratio of the Revenue generated (in %) in Macedonia in 2008 to that in 2010?
Make the answer very short. 0.91. What is the ratio of the Revenue generated (in %) of Middle East & North Africa (developing only) in 2009 to that in 2010?
Provide a short and direct response. 0.88. What is the ratio of the Revenue generated (in %) of Greece in 2009 to that in 2010?
Your answer should be very brief. 0.93. What is the ratio of the Revenue generated (in %) in Grenada in 2009 to that in 2010?
Your response must be concise. 0.46. What is the ratio of the Revenue generated (in %) of Macedonia in 2009 to that in 2010?
Make the answer very short. 0.95. What is the difference between the highest and the second highest Revenue generated (in %) of Middle East & North Africa (developing only)?
Provide a succinct answer. 2.71. What is the difference between the highest and the second highest Revenue generated (in %) of Greece?
Provide a short and direct response. 1.07. What is the difference between the highest and the second highest Revenue generated (in %) of Grenada?
Your answer should be compact. 20.64. What is the difference between the highest and the second highest Revenue generated (in %) in Macedonia?
Provide a succinct answer. 0.91. What is the difference between the highest and the lowest Revenue generated (in %) of Middle East & North Africa (developing only)?
Your response must be concise. 4. What is the difference between the highest and the lowest Revenue generated (in %) of Greece?
Provide a succinct answer. 2.42. What is the difference between the highest and the lowest Revenue generated (in %) of Grenada?
Your response must be concise. 26.76. What is the difference between the highest and the lowest Revenue generated (in %) of Macedonia?
Offer a very short reply. 4.62. 